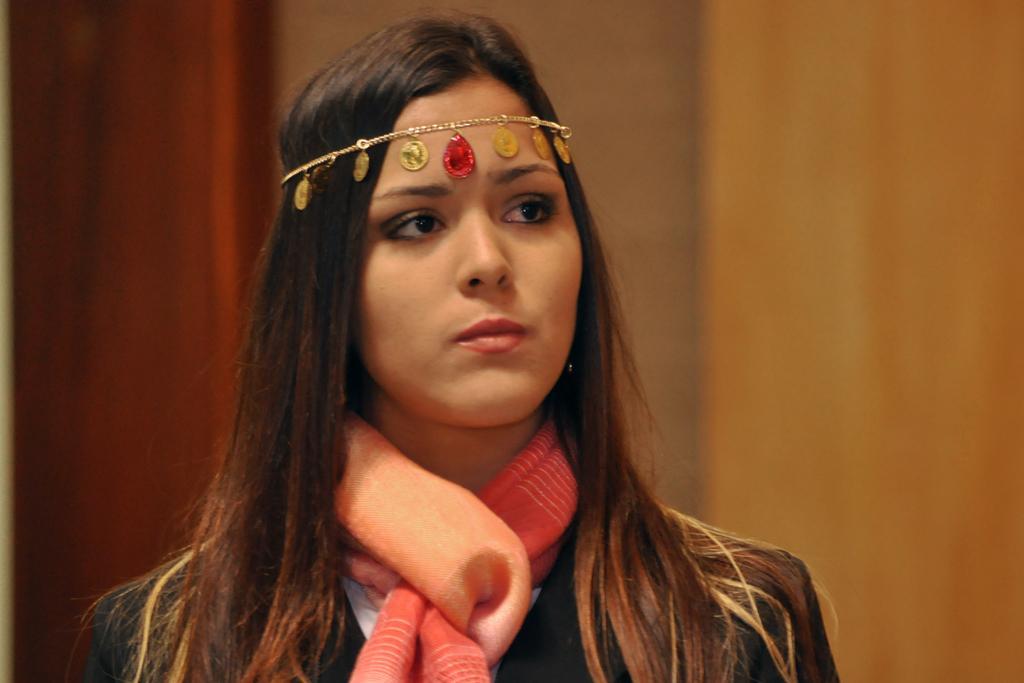Can you describe this image briefly? In this image there is a woman staring at something. 